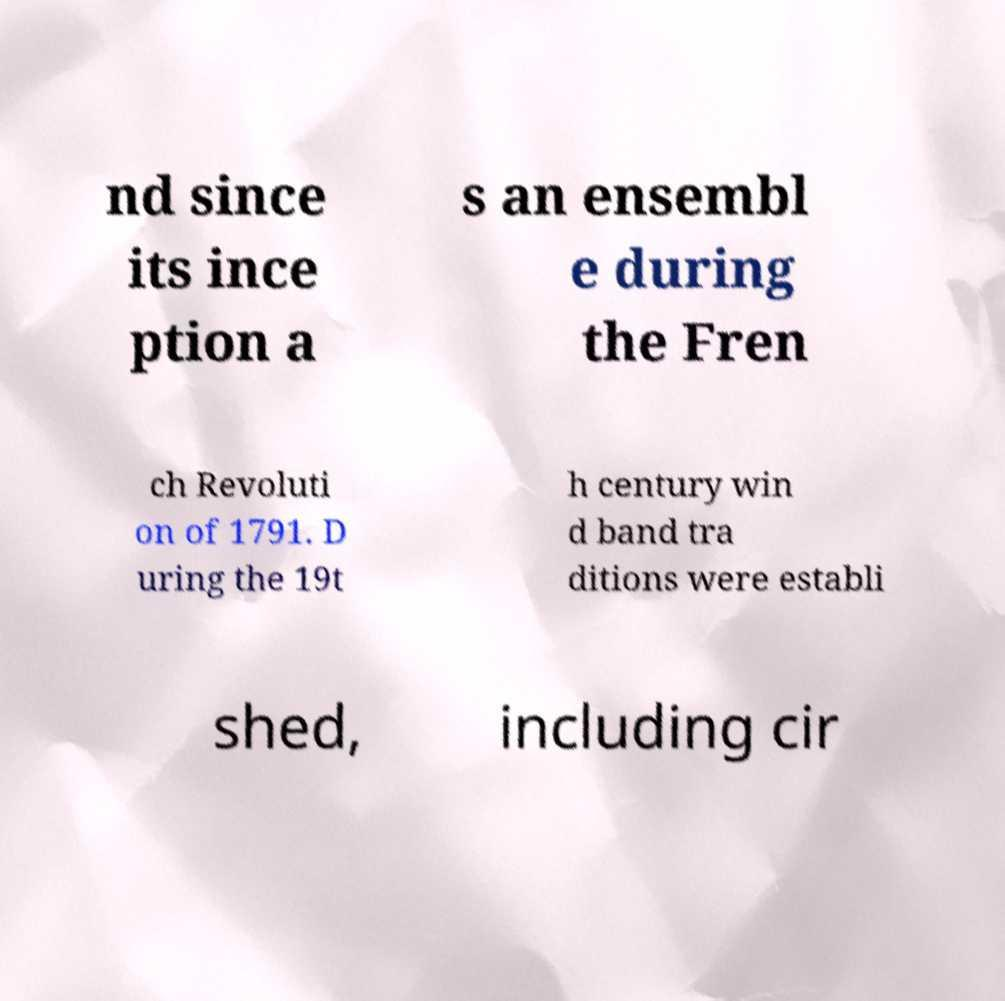Please identify and transcribe the text found in this image. nd since its ince ption a s an ensembl e during the Fren ch Revoluti on of 1791. D uring the 19t h century win d band tra ditions were establi shed, including cir 